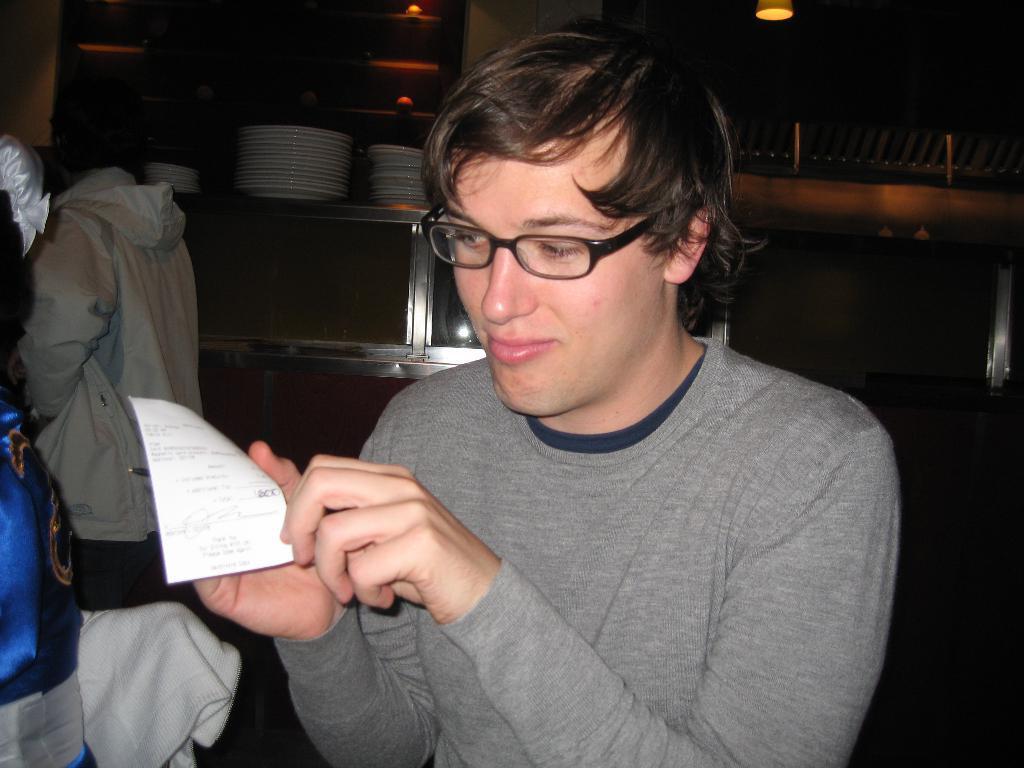Please provide a concise description of this image. In this image we can see a man who is wearing grey color t-shirt and holding paper in his hand. Background rack is there. In rack plates are arranged. Left side of the image people are standing. 